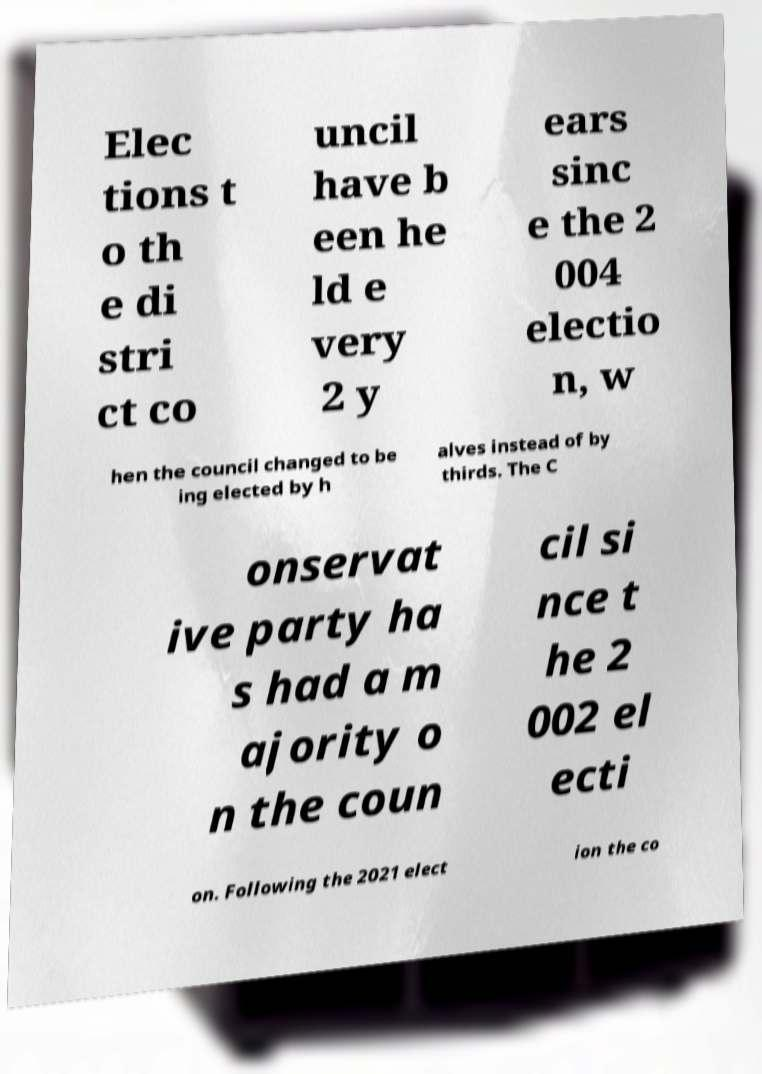What messages or text are displayed in this image? I need them in a readable, typed format. Elec tions t o th e di stri ct co uncil have b een he ld e very 2 y ears sinc e the 2 004 electio n, w hen the council changed to be ing elected by h alves instead of by thirds. The C onservat ive party ha s had a m ajority o n the coun cil si nce t he 2 002 el ecti on. Following the 2021 elect ion the co 